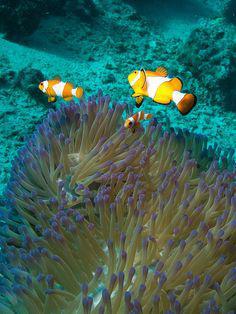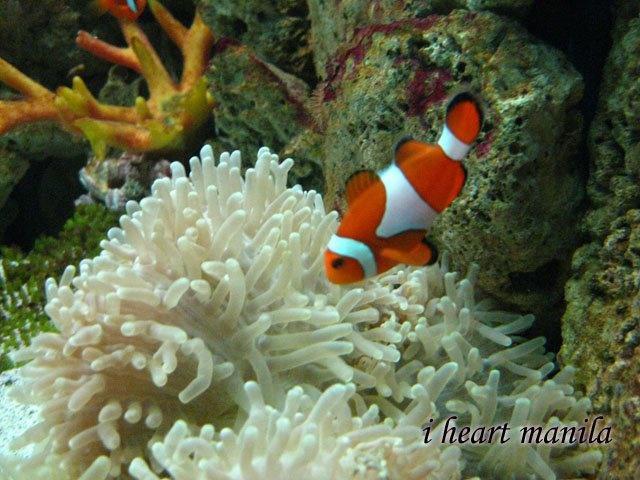The first image is the image on the left, the second image is the image on the right. Assess this claim about the two images: "One image shows exactly three orange-and-white clown fish swimming by an anemone.". Correct or not? Answer yes or no. Yes. 